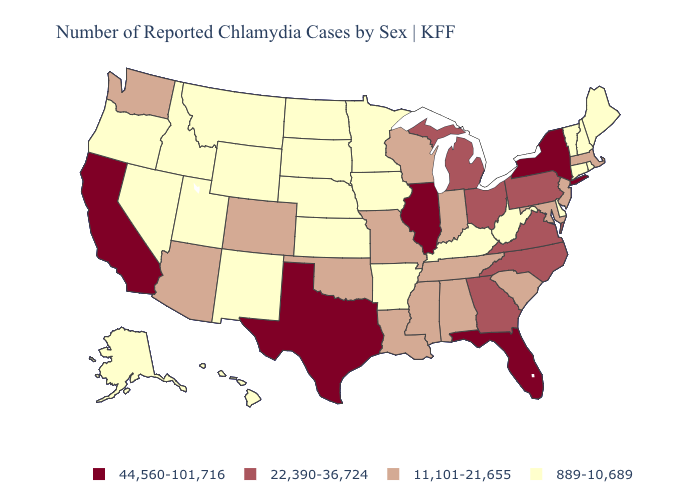Among the states that border Iowa , does Wisconsin have the lowest value?
Short answer required. No. Name the states that have a value in the range 22,390-36,724?
Write a very short answer. Georgia, Michigan, North Carolina, Ohio, Pennsylvania, Virginia. Which states have the lowest value in the Northeast?
Give a very brief answer. Connecticut, Maine, New Hampshire, Rhode Island, Vermont. Does the first symbol in the legend represent the smallest category?
Answer briefly. No. Among the states that border Texas , which have the highest value?
Give a very brief answer. Louisiana, Oklahoma. Is the legend a continuous bar?
Concise answer only. No. Name the states that have a value in the range 22,390-36,724?
Quick response, please. Georgia, Michigan, North Carolina, Ohio, Pennsylvania, Virginia. What is the value of Illinois?
Short answer required. 44,560-101,716. What is the value of Arizona?
Quick response, please. 11,101-21,655. Name the states that have a value in the range 22,390-36,724?
Keep it brief. Georgia, Michigan, North Carolina, Ohio, Pennsylvania, Virginia. What is the lowest value in the South?
Keep it brief. 889-10,689. What is the lowest value in states that border Georgia?
Give a very brief answer. 11,101-21,655. What is the value of Alabama?
Be succinct. 11,101-21,655. Does Arizona have the highest value in the USA?
Short answer required. No. 